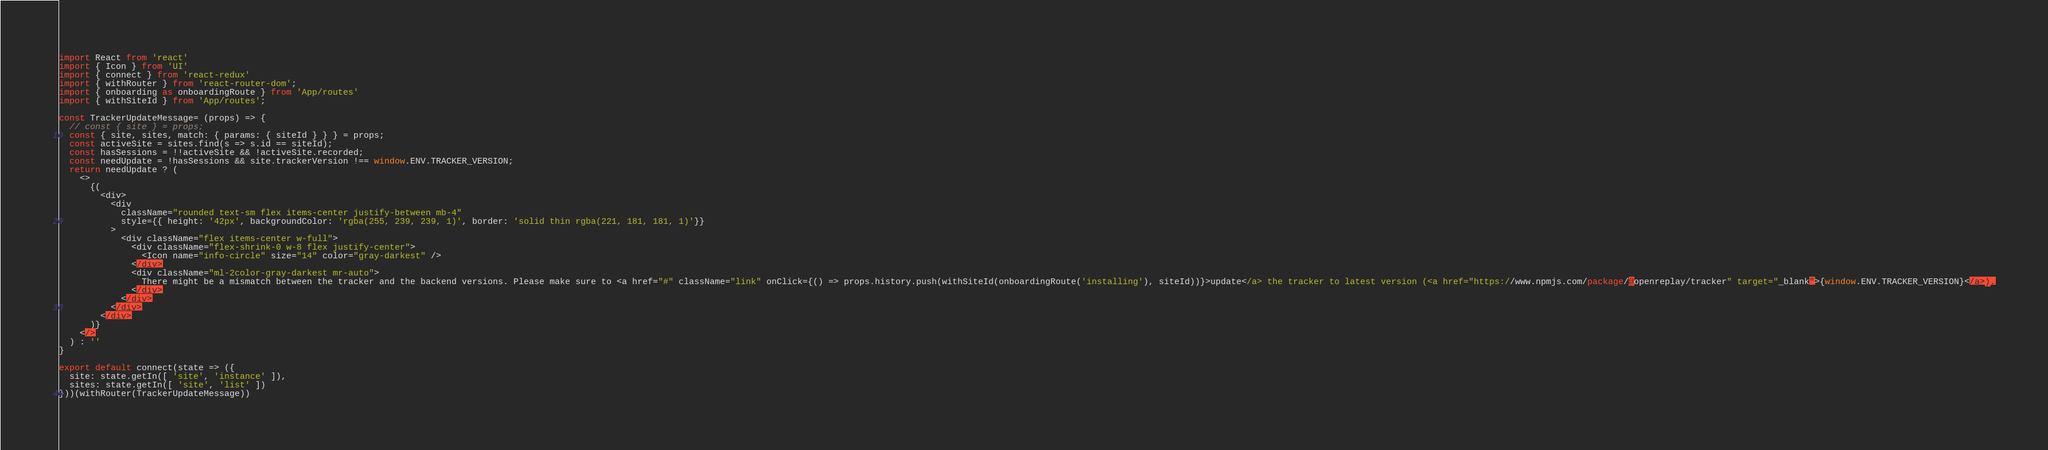Convert code to text. <code><loc_0><loc_0><loc_500><loc_500><_JavaScript_>import React from 'react'
import { Icon } from 'UI'
import { connect } from 'react-redux'
import { withRouter } from 'react-router-dom';
import { onboarding as onboardingRoute } from 'App/routes'
import { withSiteId } from 'App/routes';

const TrackerUpdateMessage= (props) => {
  // const { site } = props;
  const { site, sites, match: { params: { siteId } } } = props;
  const activeSite = sites.find(s => s.id == siteId);
  const hasSessions = !!activeSite && !activeSite.recorded;
  const needUpdate = !hasSessions && site.trackerVersion !== window.ENV.TRACKER_VERSION;
  return needUpdate ? (
    <>
      {(
        <div>
          <div
            className="rounded text-sm flex items-center justify-between mb-4"
            style={{ height: '42px', backgroundColor: 'rgba(255, 239, 239, 1)', border: 'solid thin rgba(221, 181, 181, 1)'}}
          >
            <div className="flex items-center w-full">
              <div className="flex-shrink-0 w-8 flex justify-center">
                <Icon name="info-circle" size="14" color="gray-darkest" />
              </div>
              <div className="ml-2color-gray-darkest mr-auto">
                There might be a mismatch between the tracker and the backend versions. Please make sure to <a href="#" className="link" onClick={() => props.history.push(withSiteId(onboardingRoute('installing'), siteId))}>update</a> the tracker to latest version (<a href="https://www.npmjs.com/package/@openreplay/tracker" target="_blank">{window.ENV.TRACKER_VERSION}</a>).
              </div>
            </div>
          </div>
        </div>
      )}
    </>
  ) : ''
}

export default connect(state => ({
  site: state.getIn([ 'site', 'instance' ]),
  sites: state.getIn([ 'site', 'list' ])
}))(withRouter(TrackerUpdateMessage))</code> 